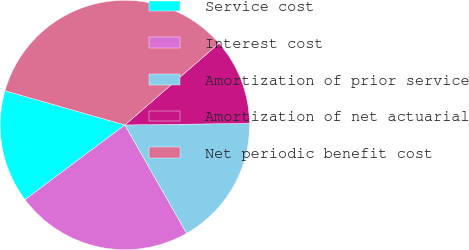Convert chart. <chart><loc_0><loc_0><loc_500><loc_500><pie_chart><fcel>Service cost<fcel>Interest cost<fcel>Amortization of prior service<fcel>Amortization of net actuarial<fcel>Net periodic benefit cost<nl><fcel>14.65%<fcel>23.03%<fcel>16.96%<fcel>11.17%<fcel>34.19%<nl></chart> 